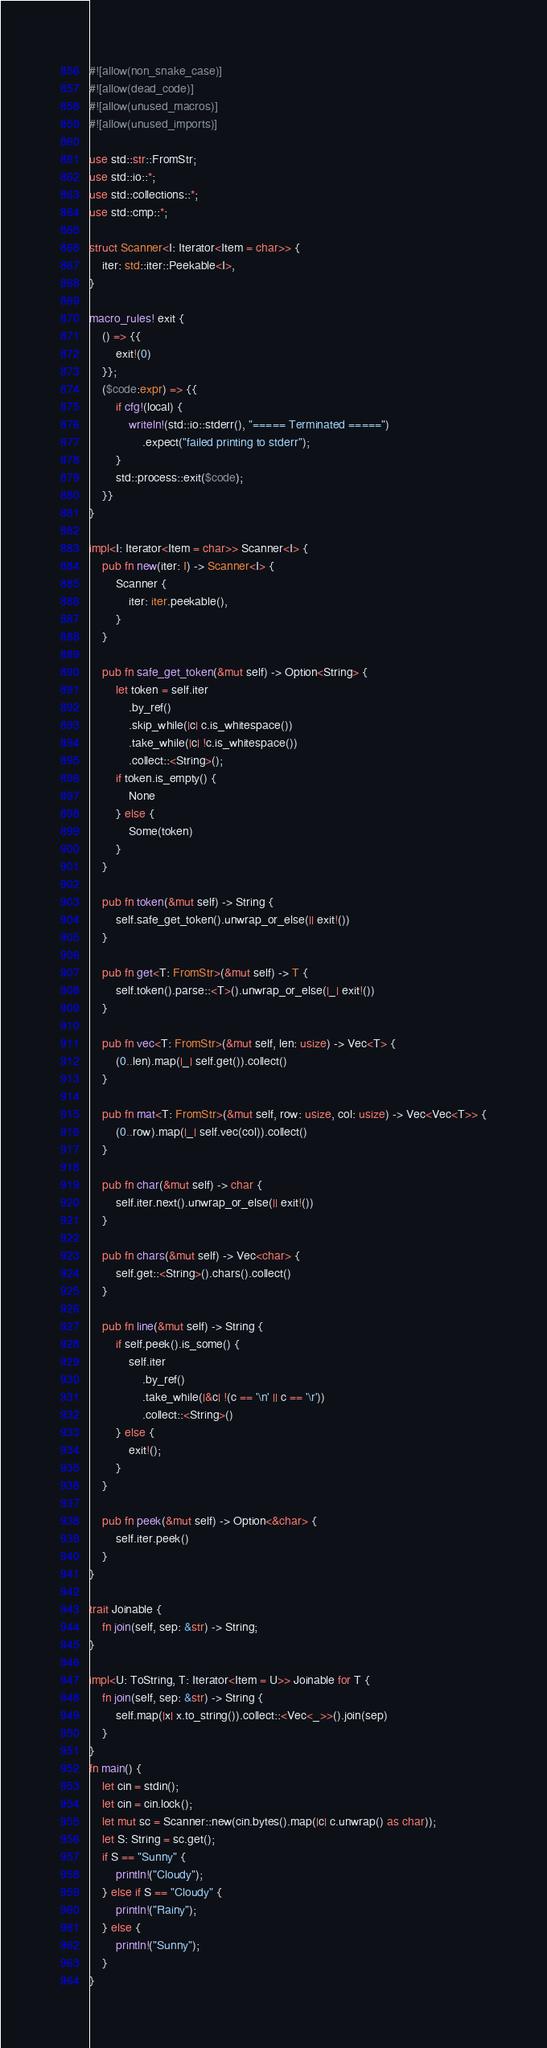<code> <loc_0><loc_0><loc_500><loc_500><_Rust_>#![allow(non_snake_case)]
#![allow(dead_code)]
#![allow(unused_macros)]
#![allow(unused_imports)]

use std::str::FromStr;
use std::io::*;
use std::collections::*;
use std::cmp::*;

struct Scanner<I: Iterator<Item = char>> {
    iter: std::iter::Peekable<I>,
}

macro_rules! exit {
    () => {{
        exit!(0)
    }};
    ($code:expr) => {{
        if cfg!(local) {
            writeln!(std::io::stderr(), "===== Terminated =====")
                .expect("failed printing to stderr");
        }
        std::process::exit($code);
    }}
}

impl<I: Iterator<Item = char>> Scanner<I> {
    pub fn new(iter: I) -> Scanner<I> {
        Scanner {
            iter: iter.peekable(),
        }
    }

    pub fn safe_get_token(&mut self) -> Option<String> {
        let token = self.iter
            .by_ref()
            .skip_while(|c| c.is_whitespace())
            .take_while(|c| !c.is_whitespace())
            .collect::<String>();
        if token.is_empty() {
            None
        } else {
            Some(token)
        }
    }

    pub fn token(&mut self) -> String {
        self.safe_get_token().unwrap_or_else(|| exit!())
    }

    pub fn get<T: FromStr>(&mut self) -> T {
        self.token().parse::<T>().unwrap_or_else(|_| exit!())
    }

    pub fn vec<T: FromStr>(&mut self, len: usize) -> Vec<T> {
        (0..len).map(|_| self.get()).collect()
    }

    pub fn mat<T: FromStr>(&mut self, row: usize, col: usize) -> Vec<Vec<T>> {
        (0..row).map(|_| self.vec(col)).collect()
    }

    pub fn char(&mut self) -> char {
        self.iter.next().unwrap_or_else(|| exit!())
    }

    pub fn chars(&mut self) -> Vec<char> {
        self.get::<String>().chars().collect()
    }

    pub fn line(&mut self) -> String {
        if self.peek().is_some() {
            self.iter
                .by_ref()
                .take_while(|&c| !(c == '\n' || c == '\r'))
                .collect::<String>()
        } else {
            exit!();
        }
    }

    pub fn peek(&mut self) -> Option<&char> {
        self.iter.peek()
    }
}

trait Joinable {
    fn join(self, sep: &str) -> String;
}

impl<U: ToString, T: Iterator<Item = U>> Joinable for T {
    fn join(self, sep: &str) -> String {
        self.map(|x| x.to_string()).collect::<Vec<_>>().join(sep)
    }
}
fn main() {
    let cin = stdin();
    let cin = cin.lock();
    let mut sc = Scanner::new(cin.bytes().map(|c| c.unwrap() as char));
    let S: String = sc.get();
    if S == "Sunny" {
        println!("Cloudy");
    } else if S == "Cloudy" {
        println!("Rainy");
    } else {
        println!("Sunny");
    }
}
</code> 